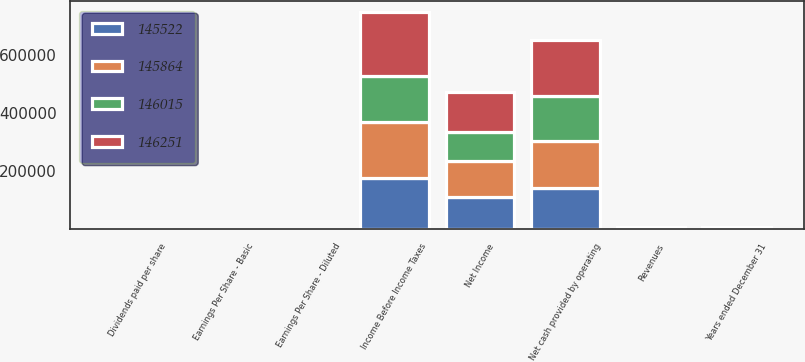Convert chart to OTSL. <chart><loc_0><loc_0><loc_500><loc_500><stacked_bar_chart><ecel><fcel>Years ended December 31<fcel>Revenues<fcel>Income Before Income Taxes<fcel>Net Income<fcel>Earnings Per Share - Basic<fcel>Earnings Per Share - Diluted<fcel>Dividends paid per share<fcel>Net cash provided by operating<nl><fcel>146251<fcel>2014<fcel>2012.5<fcel>219484<fcel>137664<fcel>0.94<fcel>0.94<fcel>0.52<fcel>194146<nl><fcel>145864<fcel>2013<fcel>2012.5<fcel>191606<fcel>123330<fcel>0.84<fcel>0.84<fcel>0.45<fcel>162665<nl><fcel>145522<fcel>2012<fcel>2012.5<fcel>176642<fcel>111332<fcel>0.76<fcel>0.76<fcel>0.44<fcel>141919<nl><fcel>146015<fcel>2011<fcel>2012.5<fcel>161096<fcel>100711<fcel>0.69<fcel>0.69<fcel>0.28<fcel>154647<nl></chart> 